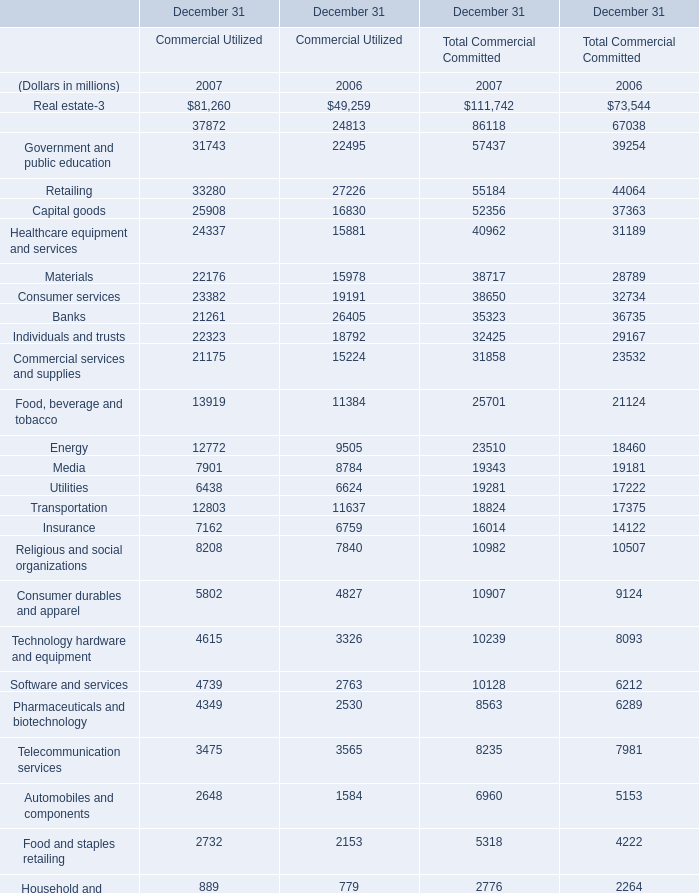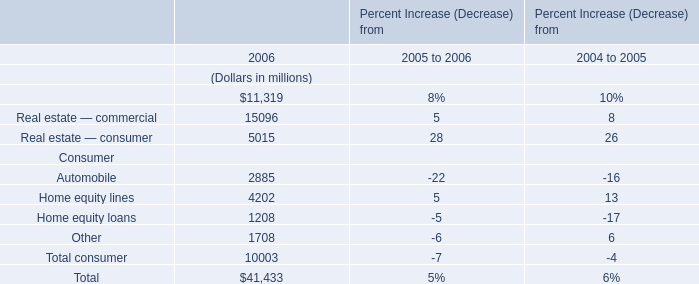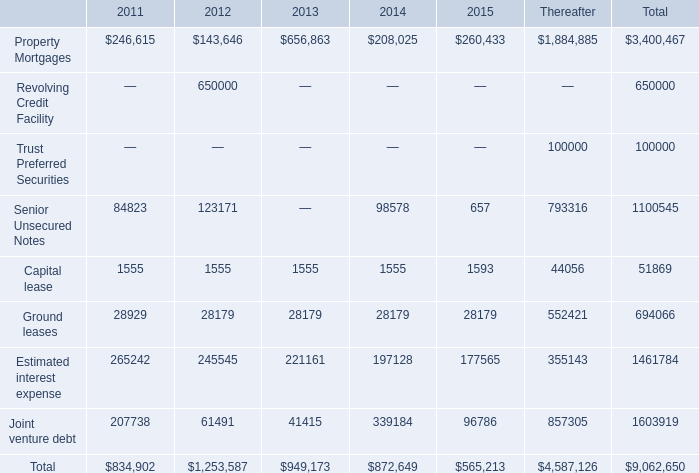What's the total amount of Real estate in 2007? (in million) 
Computations: (81260 + 111742)
Answer: 193002.0. What is the sum of Insurance of December 31 Commercial Utilized 2007, Joint venture debt of 2012, and Capital goods of December 31 Total Commercial Committed 2006 ? 
Computations: ((7162.0 + 61491.0) + 37363.0)
Answer: 106016.0. 